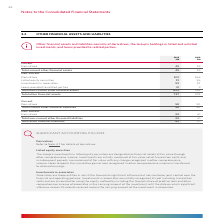According to Woolworths Limited's financial document, What is the total other financial assets in 2019? According to the financial document, 737 (in millions). The relevant text states: "ncial assets 692 522 Total other financial assets 737 575..." Also, What are associates? Associates are those entities in which the Group has significant influence but not control or joint control over the financial and operating policies.. The document states: "Associates are those entities in which the Group has significant influence but not control or joint control over the financial and operating policies...." Also, What is the unit used in the table? According to the financial document, $M. The relevant text states: "2019 2018 $M $M..." Also, can you calculate: What is the increase in total other financial assets from 2018 to 2019? Based on the calculation: 737 - 575 , the result is 162 (in millions). This is based on the information: "l assets 692 522 Total other financial assets 737 575 ncial assets 692 522 Total other financial assets 737 575..." The key data points involved are: 575, 737. Also, can you calculate: What is the percentage constitution of current derivatives in the total other financial liabilities in 2019? Based on the calculation: 58 / 82 , the result is 70.73 (percentage). This is based on the information: "abilities 24 61 Total other financial liabilities 82 111 Current Derivatives 58 50 Total current other financial liabilities 58 50 Non‑current Derivatives 24 61 Total non‑current..." The key data points involved are: 58, 82. Also, can you calculate: What is the average of the total other financial liabilities for both 2018 and 2019? To answer this question, I need to perform calculations using the financial data. The calculation is: (82 + 111)/2 , which equals 96.5 (in millions). This is based on the information: "abilities 24 61 Total other financial liabilities 82 111 lities 24 61 Total other financial liabilities 82 111..." The key data points involved are: 111, 82. 